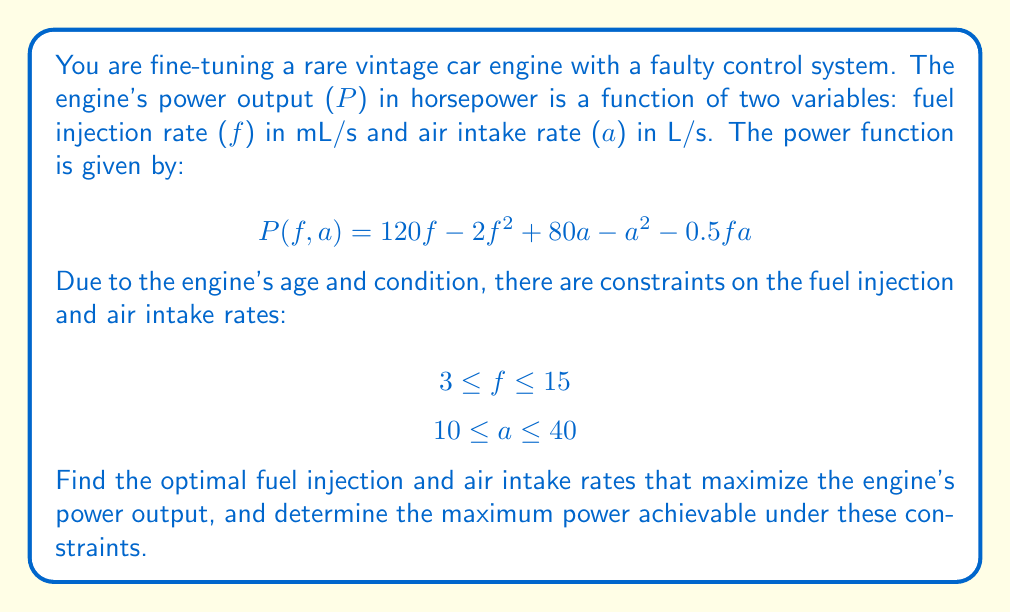What is the answer to this math problem? To solve this constrained optimization problem, we'll use the method of Lagrange multipliers. However, first, we need to check if the maximum occurs at any of the constraint boundaries or at an interior point.

Step 1: Find the critical points by taking partial derivatives and setting them to zero.

$$\frac{\partial P}{\partial f} = 120 - 4f - 0.5a = 0$$
$$\frac{\partial P}{\partial a} = 80 - 2a - 0.5f = 0$$

Step 2: Solve the system of equations.

From the second equation: $a = 40 - 0.25f$
Substituting into the first equation:
$120 - 4f - 0.5(40 - 0.25f) = 0$
$120 - 4f - 20 + 0.125f = 0$
$100 - 3.875f = 0$
$f = 25.81$

This gives us $a = 40 - 0.25(25.81) = 33.55$

Step 3: Check if the critical point is within the constraints.

The fuel injection rate $f = 25.81$ is outside the constraint $3 \leq f \leq 15$, so this critical point is not valid.

Step 4: Check the constraint boundaries.

We need to check the following points:
(3, 10), (3, 40), (15, 10), (15, 40), and the lines f = 3, f = 15, a = 10, a = 40.

Evaluating P at the corner points:
P(3, 10) = 1024.5
P(3, 40) = 2584.5
P(15, 10) = 1372.5
P(15, 40) = 2332.5

Now, let's check the boundary lines:

For f = 3:
P(3, a) = 360 - 6 + 80a - a^2 - 1.5a = -a^2 + 78.5a + 354
Setting dP/da = 0: -2a + 78.5 = 0, a = 39.25
This is within the constraints, so we evaluate P(3, 39.25) = 2585.78

For f = 15:
P(15, a) = 1800 - 450 + 80a - a^2 - 7.5a = -a^2 + 72.5a + 1350
Setting dP/da = 0: -2a + 72.5 = 0, a = 36.25
This is within the constraints, so we evaluate P(15, 36.25) = 2335.16

For a = 10:
P(f, 10) = 120f - 2f^2 + 800 - 100 - 5f = -2f^2 + 115f + 700
Setting dP/df = 0: -4f + 115 = 0, f = 28.75
This is outside the constraints, so we need to check the endpoints f = 3 and f = 15.
We've already calculated these values: P(3, 10) = 1024.5 and P(15, 10) = 1372.5

For a = 40:
P(f, 40) = 120f - 2f^2 + 3200 - 1600 - 20f = -2f^2 + 100f + 1600
Setting dP/df = 0: -4f + 100 = 0, f = 25
This is outside the constraints, so we need to check the endpoints f = 3 and f = 15.
We've already calculated these values: P(3, 40) = 2584.5 and P(15, 40) = 2332.5

Step 5: Compare all the valid maximum points to find the global maximum.

The highest power output is 2585.78 HP, occurring at f = 3 mL/s and a = 39.25 L/s.
Answer: The optimal fuel injection rate is 3 mL/s, and the optimal air intake rate is 39.25 L/s. The maximum power output achievable under these constraints is 2585.78 HP. 